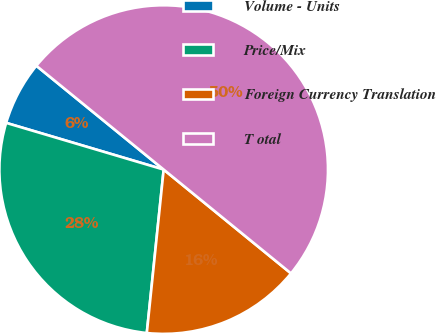<chart> <loc_0><loc_0><loc_500><loc_500><pie_chart><fcel>Volume - Units<fcel>Price/Mix<fcel>Foreign Currency Translation<fcel>T otal<nl><fcel>6.3%<fcel>27.95%<fcel>15.75%<fcel>50.0%<nl></chart> 